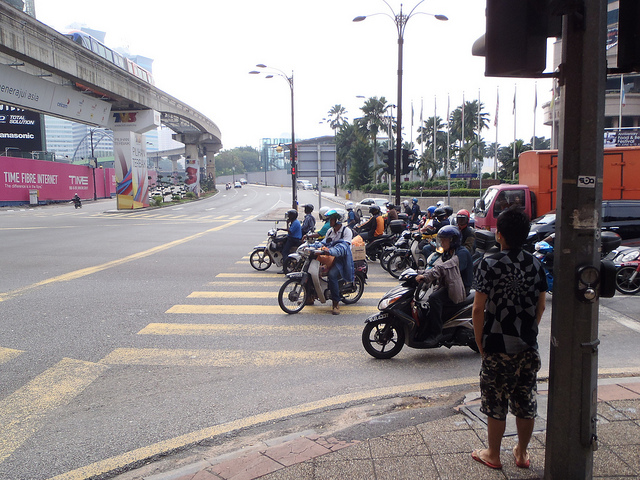<image>What kind of shoes is the standing person wearing? It is ambiguous what kind of shoes the standing person is wearing. It could be flip flops, sandals or none. What kind of shoes is the standing person wearing? I am not sure what kind of shoes the standing person is wearing. It can be seen 'flip flops', 'sandals' or none at all. 